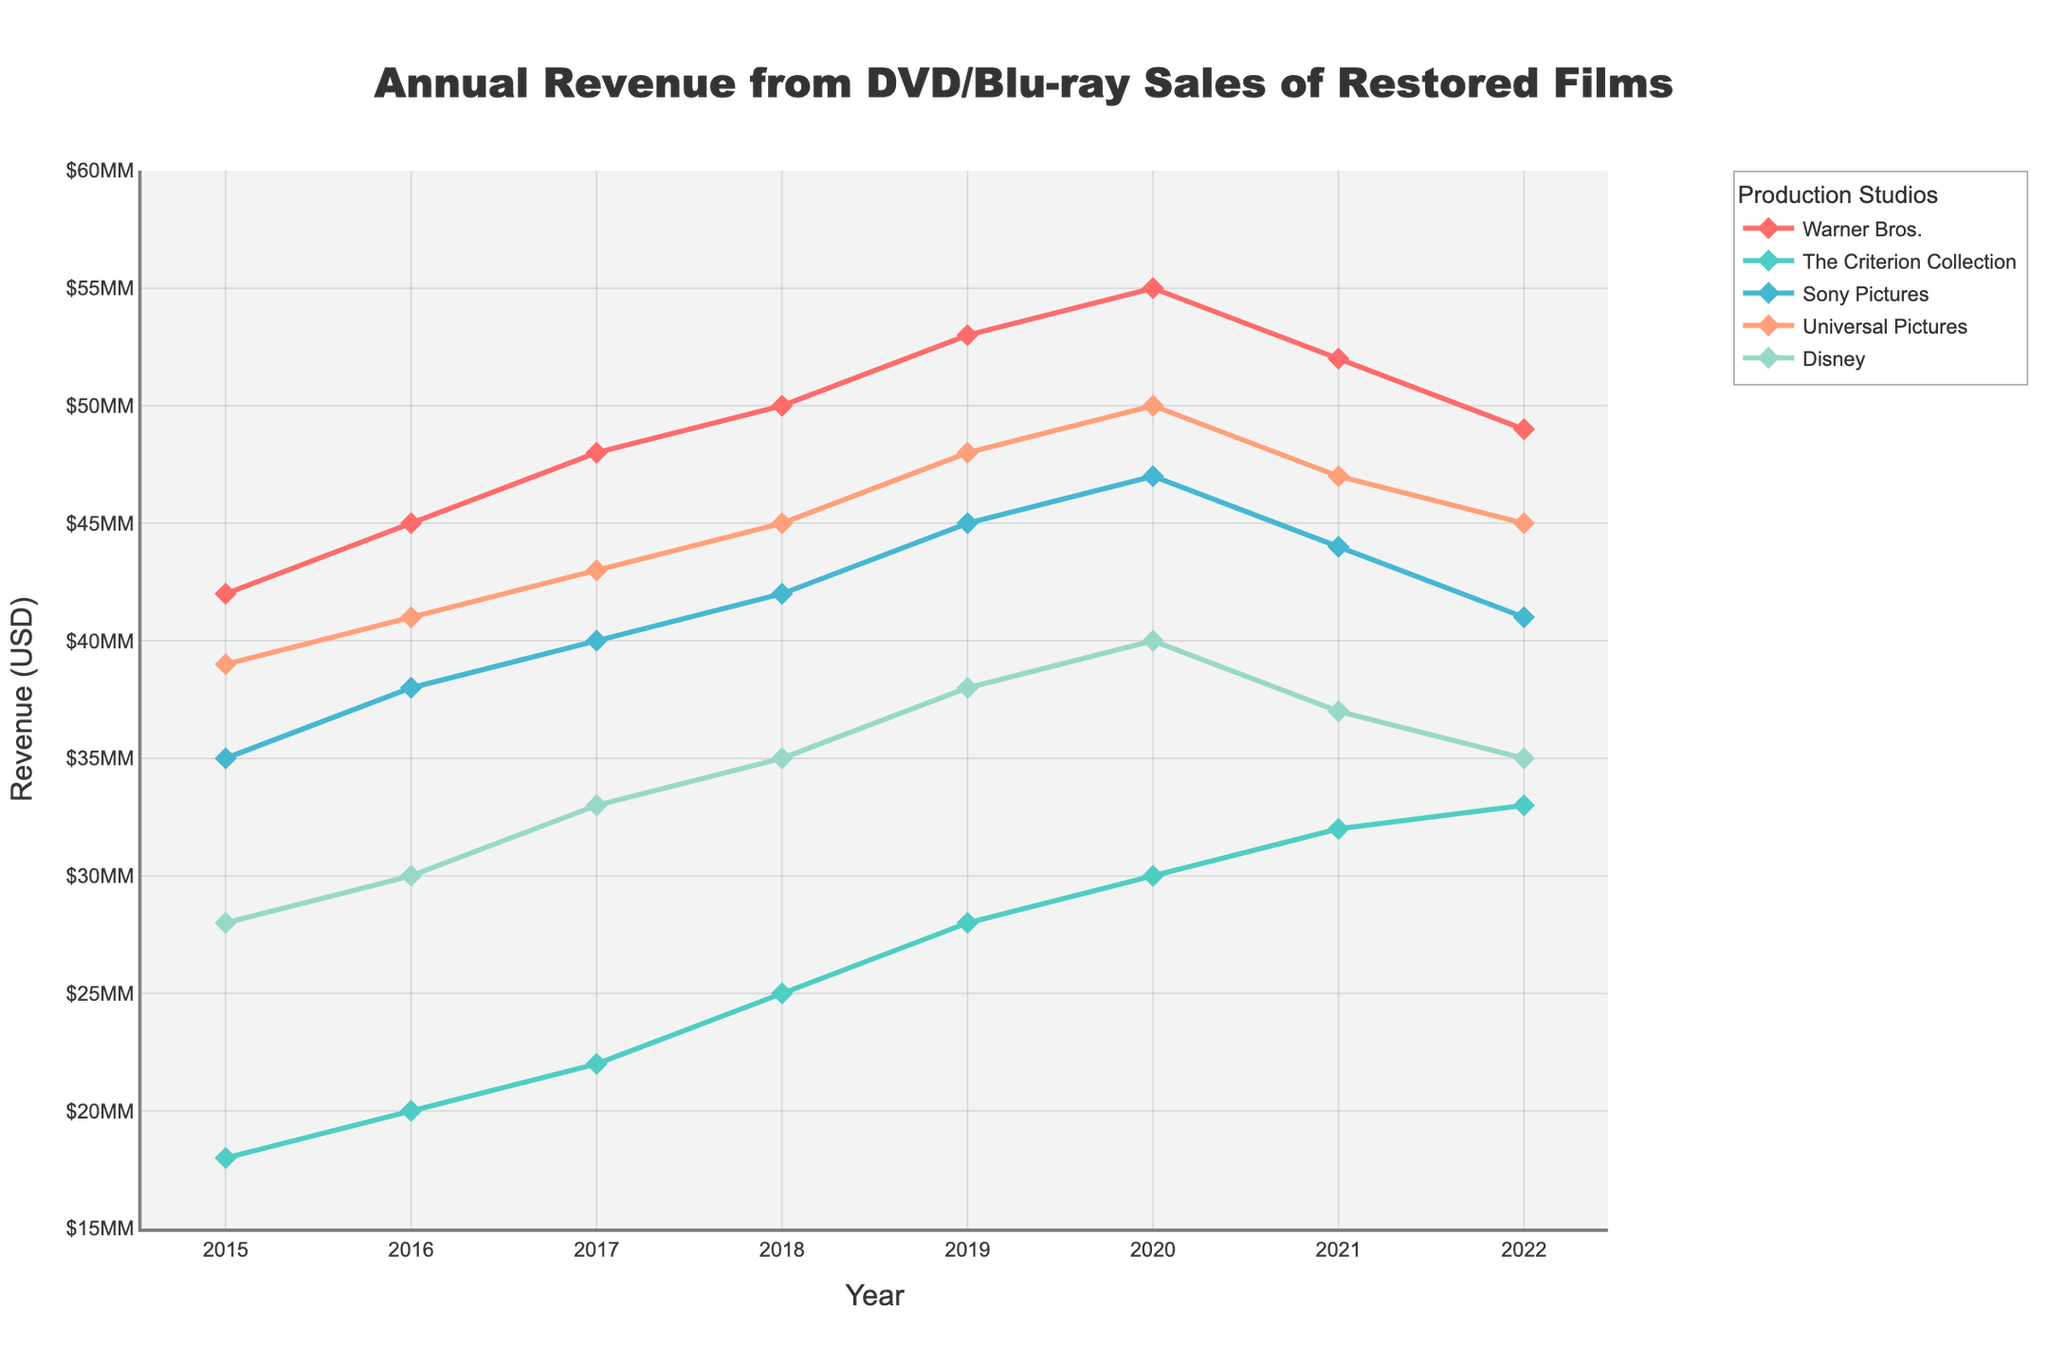How did Warner Bros.' revenue change from 2019 to 2022? To determine this, look at the revenue values for Warner Bros. in 2019 and 2022. The value drops from $53,000,000 in 2019 to $49,000,000 in 2022.
Answer: Decreased by $4,000,000 Which studio had the highest revenue in 2020, and what was it? The highest revenue value for 2020 is found by checking all the studios' revenues for that year. Universal Pictures has the highest revenue at $50,000,000.
Answer: Universal Pictures, $50,000,000 What is the total revenue from DVD/Blu-ray sales for Disney over the 8 years? Sum the yearly revenues of Disney from 2015 to 2022: $28,000,000 + $30,000,000 + $33,000,000 + $35,000,000 + $38,000,000 + $40,000,000 + $37,000,000 + $35,000,000 = $276,000,000
Answer: $276,000,000 Which studio shows the most consistent revenue growth from 2015 to 2020? To judge consistency, look for linear and regular increments each year. The Criterion Collection shows a consistent increase from $18,000,000 in 2015 to $30,000,000 in 2020, increasing by $2,000,000 each year.
Answer: The Criterion Collection How did the revenue for The Criterion Collection in 2021 compare to its peak revenue over the years? The peak revenue for The Criterion Collection is in 2021 at $32,000,000. Since 2021 is part of the dataset, it is the peak.
Answer: $32,000,000 (Peak) Which two studios' revenues converged the most closely in 2022? Compare the revenue figures for each studio in 2022: Warner Bros. ($49,000,000), The Criterion Collection ($33,000,000), Sony Pictures ($41,000,000), Universal Pictures ($45,000,000), Disney ($35,000,000). The closest are Sony Pictures and Universal Pictures ($41,000,000 and $45,000,000, respectively).
Answer: Sony Pictures and Universal Pictures What was the trend for Sony Pictures' revenue from 2021 to 2022? To find the trend, compare Sony Pictures' revenue in 2021 ($44,000,000) and 2022 ($41,000,000). The revenue decreased.
Answer: Decreasing From 2015 to 2022, which year showed the highest overall revenue for all studios combined? Calculate the total revenue for each year by summing up all studios' revenue for that year. The year with the highest total is 2020: $55M + $30M + $47M + $50M + $40M = $222M.
Answer: 2020 Looking at the data, which studio had the least variation in revenue over the years? To find the least variation, look for the flattest line or smallest changes year to year. Sony Pictures shows the least variation, with revenues varying from $35,000,000 to $47,000,000.
Answer: Sony Pictures 